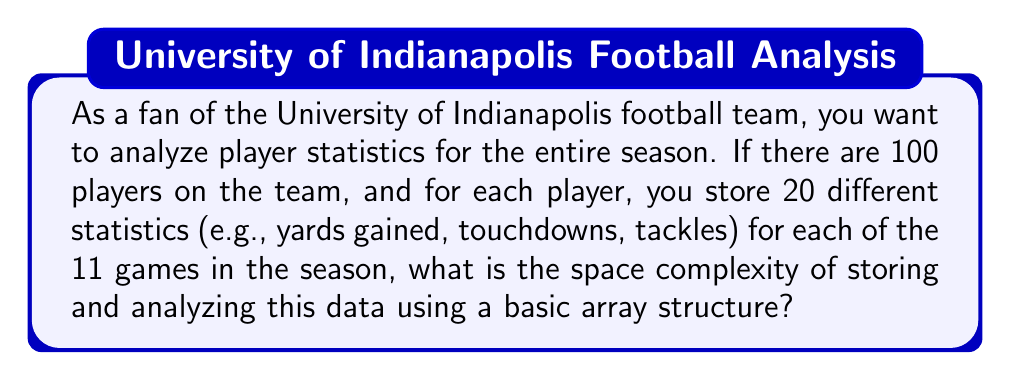Could you help me with this problem? Let's break this down step-by-step:

1) First, we need to identify the variables:
   - Number of players: 100
   - Number of statistics per player: 20
   - Number of games in the season: 11

2) In a basic array structure, we would need a 3-dimensional array to store this data:
   - 1st dimension: players
   - 2nd dimension: statistics
   - 3rd dimension: games

3) The total number of data points we need to store is:
   $$ 100 \text{ players} \times 20 \text{ statistics} \times 11 \text{ games} = 22,000 \text{ data points} $$

4) In computational complexity theory, we're interested in how the space requirements grow as the input size increases. We express this using Big O notation.

5) In this case, if we let:
   - $n$ be the number of players
   - $s$ be the number of statistics per player
   - $g$ be the number of games

   Then the space required is proportional to $n \times s \times g$.

6) In Big O notation, we typically express this as $O(nsg)$.

7) However, in this specific problem, $s$ and $g$ are fixed values (20 and 11 respectively), while $n$ (the number of players) is the variable that could potentially increase.

8) When some factors are constant, we can simplify the Big O notation by dropping those constant factors. So in this case, we can simplify $O(nsg)$ to $O(n)$.

Therefore, the space complexity for storing and analyzing this data is $O(n)$, where $n$ is the number of players.
Answer: $O(n)$, where $n$ is the number of players. 